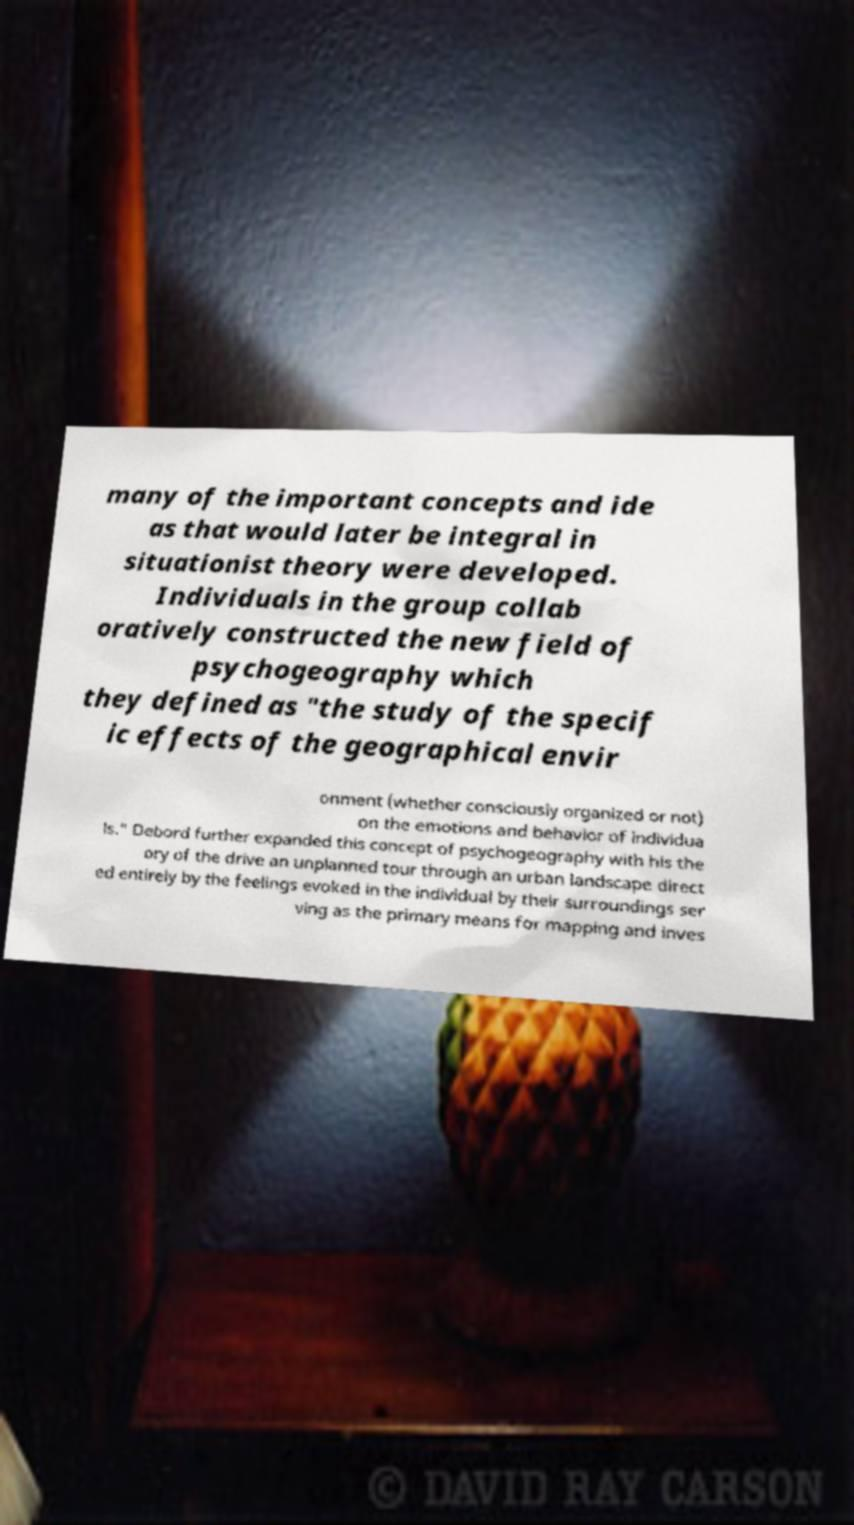Please identify and transcribe the text found in this image. many of the important concepts and ide as that would later be integral in situationist theory were developed. Individuals in the group collab oratively constructed the new field of psychogeography which they defined as "the study of the specif ic effects of the geographical envir onment (whether consciously organized or not) on the emotions and behavior of individua ls." Debord further expanded this concept of psychogeography with his the ory of the drive an unplanned tour through an urban landscape direct ed entirely by the feelings evoked in the individual by their surroundings ser ving as the primary means for mapping and inves 